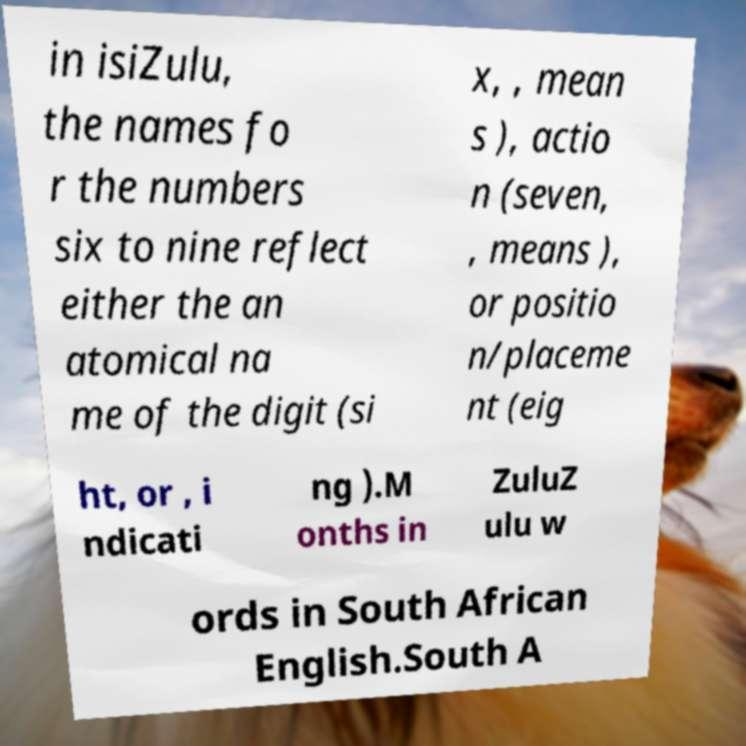What messages or text are displayed in this image? I need them in a readable, typed format. in isiZulu, the names fo r the numbers six to nine reflect either the an atomical na me of the digit (si x, , mean s ), actio n (seven, , means ), or positio n/placeme nt (eig ht, or , i ndicati ng ).M onths in ZuluZ ulu w ords in South African English.South A 